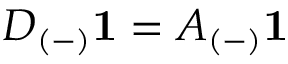Convert formula to latex. <formula><loc_0><loc_0><loc_500><loc_500>D _ { ( - ) } 1 = A _ { ( - ) } 1</formula> 